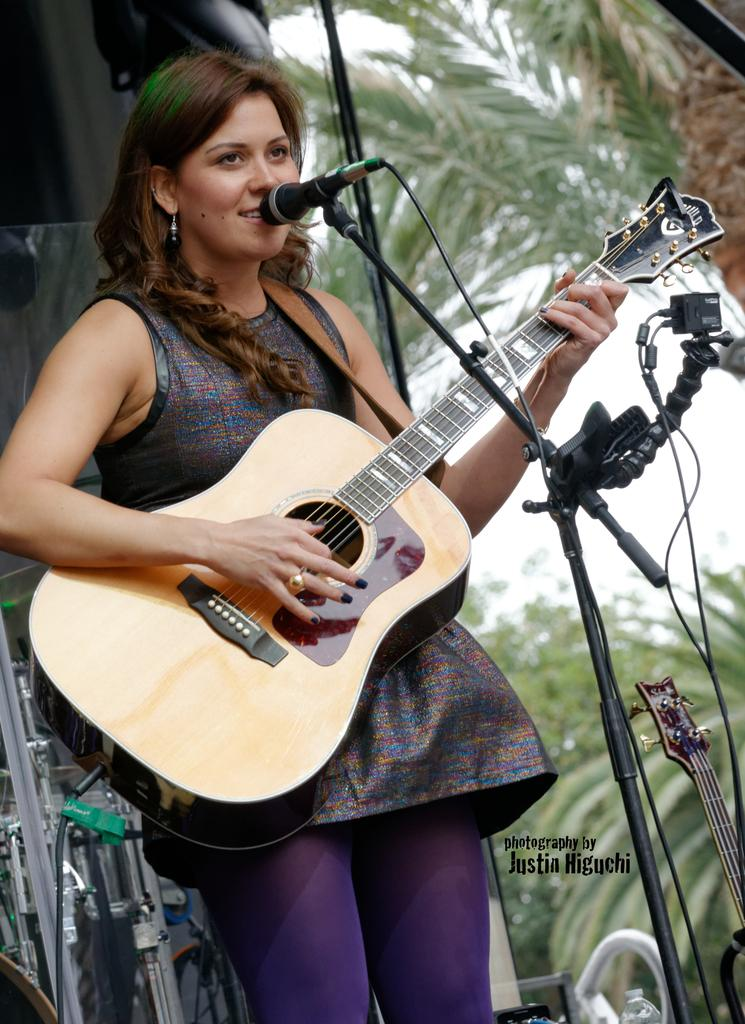What is the main subject of the image? The main subject of the image is a woman. Can you describe the woman's appearance? The woman's hair is short. What is the woman doing in the image? The woman is singing and playing a guitar. What objects are present in the image that are related to the woman's activities? There is a microphone and a guitar in the image. What can be seen in the background of the image? There are trees and the sky visible in the background of the image. How many friends is the woman using the guitar with in the image? The image does not show any friends, and the woman is not using the guitar with anyone. What type of ray is emitted from the guitar in the image? There is no ray emitted from the guitar in the image. 